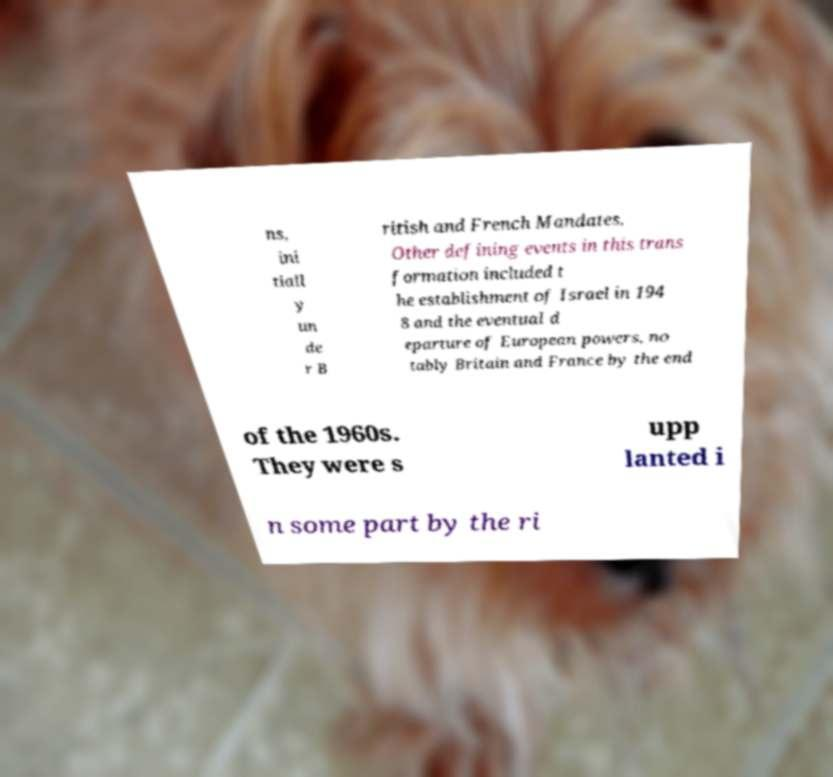There's text embedded in this image that I need extracted. Can you transcribe it verbatim? ns, ini tiall y un de r B ritish and French Mandates. Other defining events in this trans formation included t he establishment of Israel in 194 8 and the eventual d eparture of European powers, no tably Britain and France by the end of the 1960s. They were s upp lanted i n some part by the ri 